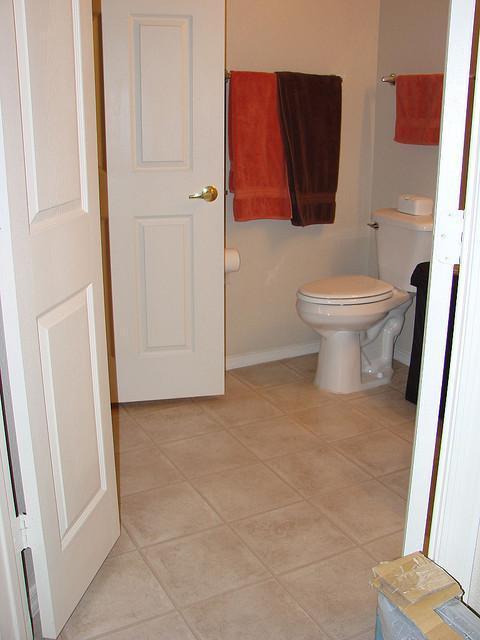How many towels are in the bathroom?
Give a very brief answer. 3. How many kites are in the sky?
Give a very brief answer. 0. 